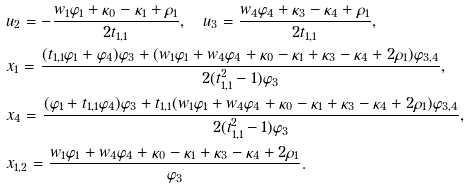Convert formula to latex. <formula><loc_0><loc_0><loc_500><loc_500>& u _ { 2 } = - \frac { w _ { 1 } \varphi _ { 1 } + \kappa _ { 0 } - \kappa _ { 1 } + \rho _ { 1 } } { 2 t _ { 1 , 1 } } , \quad u _ { 3 } = \frac { w _ { 4 } \varphi _ { 4 } + \kappa _ { 3 } - \kappa _ { 4 } + \rho _ { 1 } } { 2 t _ { 1 , 1 } } , \\ & x _ { 1 } = \frac { ( t _ { 1 , 1 } \varphi _ { 1 } + \varphi _ { 4 } ) \varphi _ { 3 } + ( w _ { 1 } \varphi _ { 1 } + w _ { 4 } \varphi _ { 4 } + \kappa _ { 0 } - \kappa _ { 1 } + \kappa _ { 3 } - \kappa _ { 4 } + 2 \rho _ { 1 } ) \varphi _ { 3 , 4 } } { 2 ( t _ { 1 , 1 } ^ { 2 } - 1 ) \varphi _ { 3 } } , \\ & x _ { 4 } = \frac { ( \varphi _ { 1 } + t _ { 1 , 1 } \varphi _ { 4 } ) \varphi _ { 3 } + t _ { 1 , 1 } ( w _ { 1 } \varphi _ { 1 } + w _ { 4 } \varphi _ { 4 } + \kappa _ { 0 } - \kappa _ { 1 } + \kappa _ { 3 } - \kappa _ { 4 } + 2 \rho _ { 1 } ) \varphi _ { 3 , 4 } } { 2 ( t _ { 1 , 1 } ^ { 2 } - 1 ) \varphi _ { 3 } } , \\ & x _ { 1 , 2 } = \frac { w _ { 1 } \varphi _ { 1 } + w _ { 4 } \varphi _ { 4 } + \kappa _ { 0 } - \kappa _ { 1 } + \kappa _ { 3 } - \kappa _ { 4 } + 2 \rho _ { 1 } } { \varphi _ { 3 } } .</formula> 